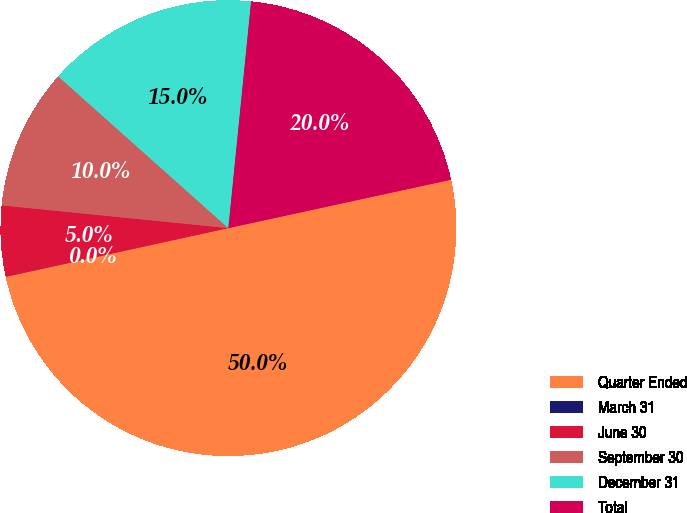Convert chart to OTSL. <chart><loc_0><loc_0><loc_500><loc_500><pie_chart><fcel>Quarter Ended<fcel>March 31<fcel>June 30<fcel>September 30<fcel>December 31<fcel>Total<nl><fcel>49.98%<fcel>0.01%<fcel>5.01%<fcel>10.0%<fcel>15.0%<fcel>20.0%<nl></chart> 